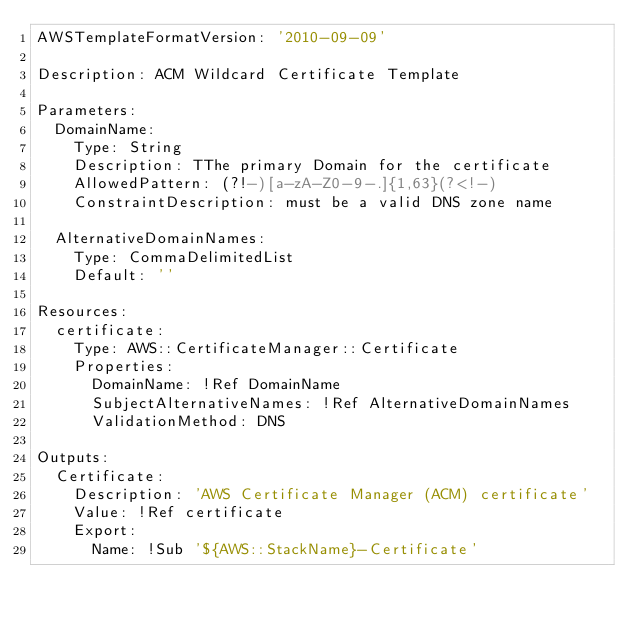Convert code to text. <code><loc_0><loc_0><loc_500><loc_500><_YAML_>AWSTemplateFormatVersion: '2010-09-09'

Description: ACM Wildcard Certificate Template

Parameters:
  DomainName:
    Type: String
    Description: TThe primary Domain for the certificate
    AllowedPattern: (?!-)[a-zA-Z0-9-.]{1,63}(?<!-)
    ConstraintDescription: must be a valid DNS zone name

  AlternativeDomainNames:
    Type: CommaDelimitedList
    Default: ''

Resources:
  certificate:
    Type: AWS::CertificateManager::Certificate
    Properties:
      DomainName: !Ref DomainName
      SubjectAlternativeNames: !Ref AlternativeDomainNames
      ValidationMethod: DNS

Outputs:
  Certificate:
    Description: 'AWS Certificate Manager (ACM) certificate'
    Value: !Ref certificate
    Export:
      Name: !Sub '${AWS::StackName}-Certificate'
</code> 